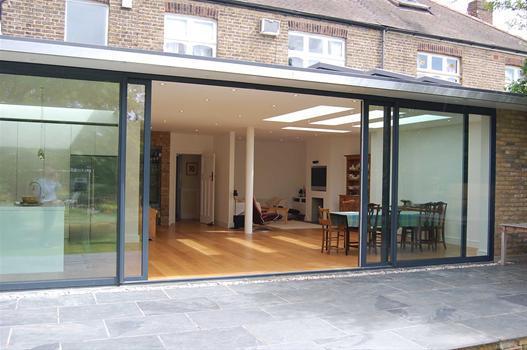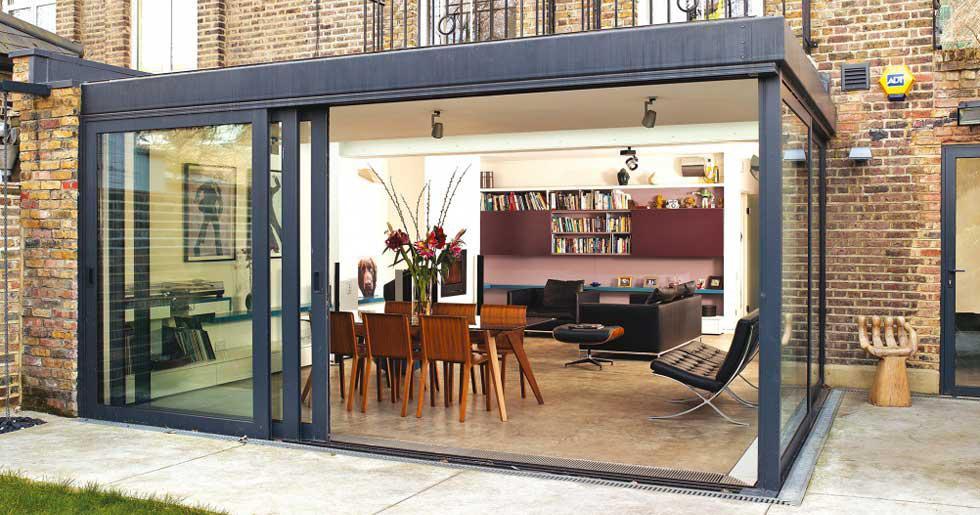The first image is the image on the left, the second image is the image on the right. Assess this claim about the two images: "At least one door has white trim.". Correct or not? Answer yes or no. No. The first image is the image on the left, the second image is the image on the right. Assess this claim about the two images: "There are two exterior views of open glass panels that open to the outside.". Correct or not? Answer yes or no. Yes. 